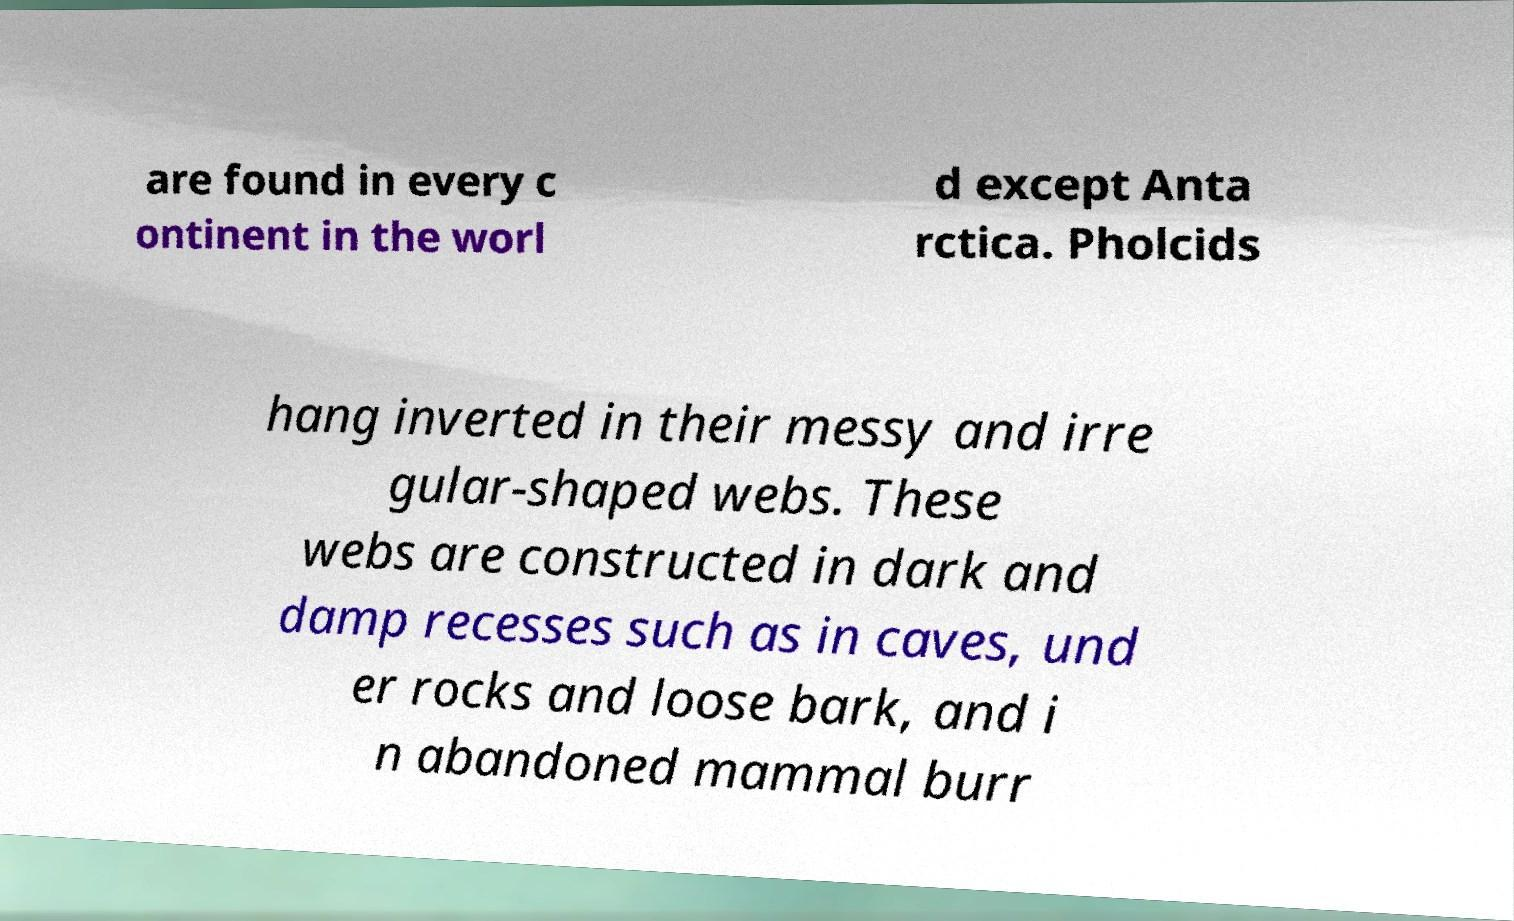For documentation purposes, I need the text within this image transcribed. Could you provide that? are found in every c ontinent in the worl d except Anta rctica. Pholcids hang inverted in their messy and irre gular-shaped webs. These webs are constructed in dark and damp recesses such as in caves, und er rocks and loose bark, and i n abandoned mammal burr 